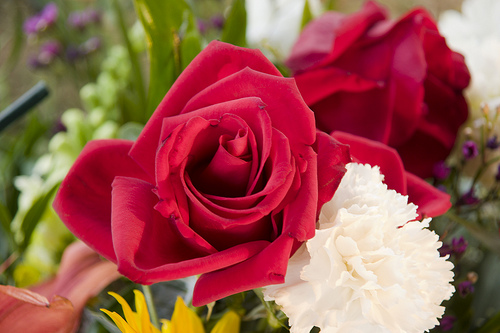<image>
Can you confirm if the rose is to the right of the chrysanthemum? No. The rose is not to the right of the chrysanthemum. The horizontal positioning shows a different relationship. 